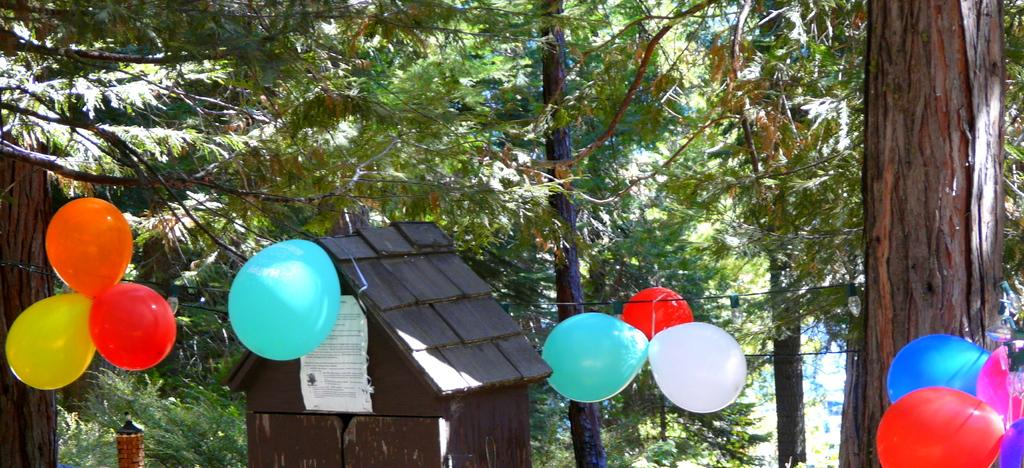What type of objects can be seen floating in the image? There are colorful balloons in the image. What is the wire used for in the image? The wire is not explicitly described in the facts, so we cannot determine its purpose. What is the main feature of the tree in the image? The tree has a tree trunk in the image. What type of structure is present in the image? There is a shed with doors in the image. What is attached to the shed in the image? There is a poster attached to the shed in the image. How many beggars are visible in the image? There are no beggars present in the image. What type of pies are being sold in the image? There is no mention of pies in the image. 